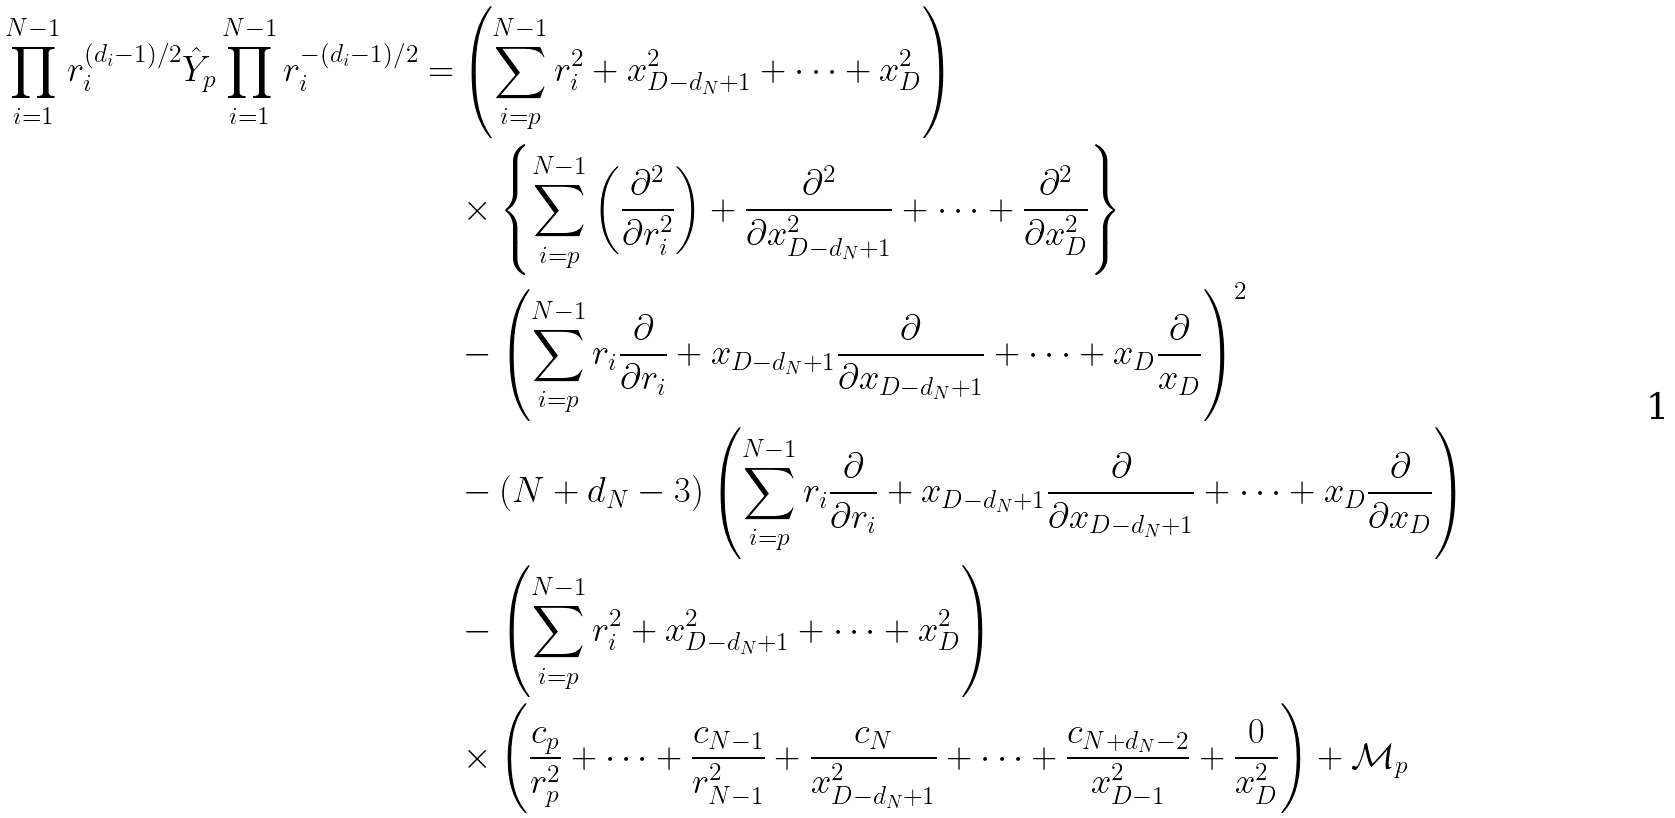<formula> <loc_0><loc_0><loc_500><loc_500>\prod _ { i = 1 } ^ { N - 1 } r _ { i } ^ { ( d _ { i } - 1 ) / 2 } \hat { Y } _ { p } \prod _ { i = 1 } ^ { N - 1 } r _ { i } ^ { - ( d _ { i } - 1 ) / 2 } = & \left ( \sum _ { i = p } ^ { N - 1 } r _ { i } ^ { 2 } + x _ { D - d _ { N } + 1 } ^ { 2 } + \cdots + x _ { D } ^ { 2 } \right ) \\ & \times \left \{ \sum _ { i = p } ^ { N - 1 } \left ( \frac { \partial ^ { 2 } } { \partial r _ { i } ^ { 2 } } \right ) + \frac { \partial ^ { 2 } } { \partial x _ { D - d _ { N } + 1 } ^ { 2 } } + \cdots + \frac { \partial ^ { 2 } } { \partial x _ { D } ^ { 2 } } \right \} \\ & - \left ( \sum _ { i = p } ^ { N - 1 } r _ { i } \frac { \partial } { \partial r _ { i } } + x _ { D - d _ { N } + 1 } \frac { \partial } { \partial x _ { D - d _ { N } + 1 } } + \cdots + x _ { D } \frac { \partial } { x _ { D } } \right ) ^ { 2 } \\ & - ( N + d _ { N } - 3 ) \left ( \sum _ { i = p } ^ { N - 1 } r _ { i } \frac { \partial } { \partial r _ { i } } + x _ { D - d _ { N } + 1 } \frac { \partial } { \partial x _ { D - d _ { N } + 1 } } + \cdots + x _ { D } \frac { \partial } { \partial x _ { D } } \right ) \\ & - \left ( \sum _ { i = p } ^ { N - 1 } r _ { i } ^ { 2 } + x _ { D - d _ { N } + 1 } ^ { 2 } + \cdots + x _ { D } ^ { 2 } \right ) \\ & \times \left ( \frac { c _ { p } } { r _ { p } ^ { 2 } } + \cdots + \frac { c _ { N - 1 } } { r _ { N - 1 } ^ { 2 } } + \frac { c _ { N } } { x _ { D - d _ { N } + 1 } ^ { 2 } } + \cdots + \frac { c _ { N + d _ { N } - 2 } } { x _ { D - 1 } ^ { 2 } } + \frac { 0 } { x _ { D } ^ { 2 } } \right ) + \mathcal { M } _ { p }</formula> 